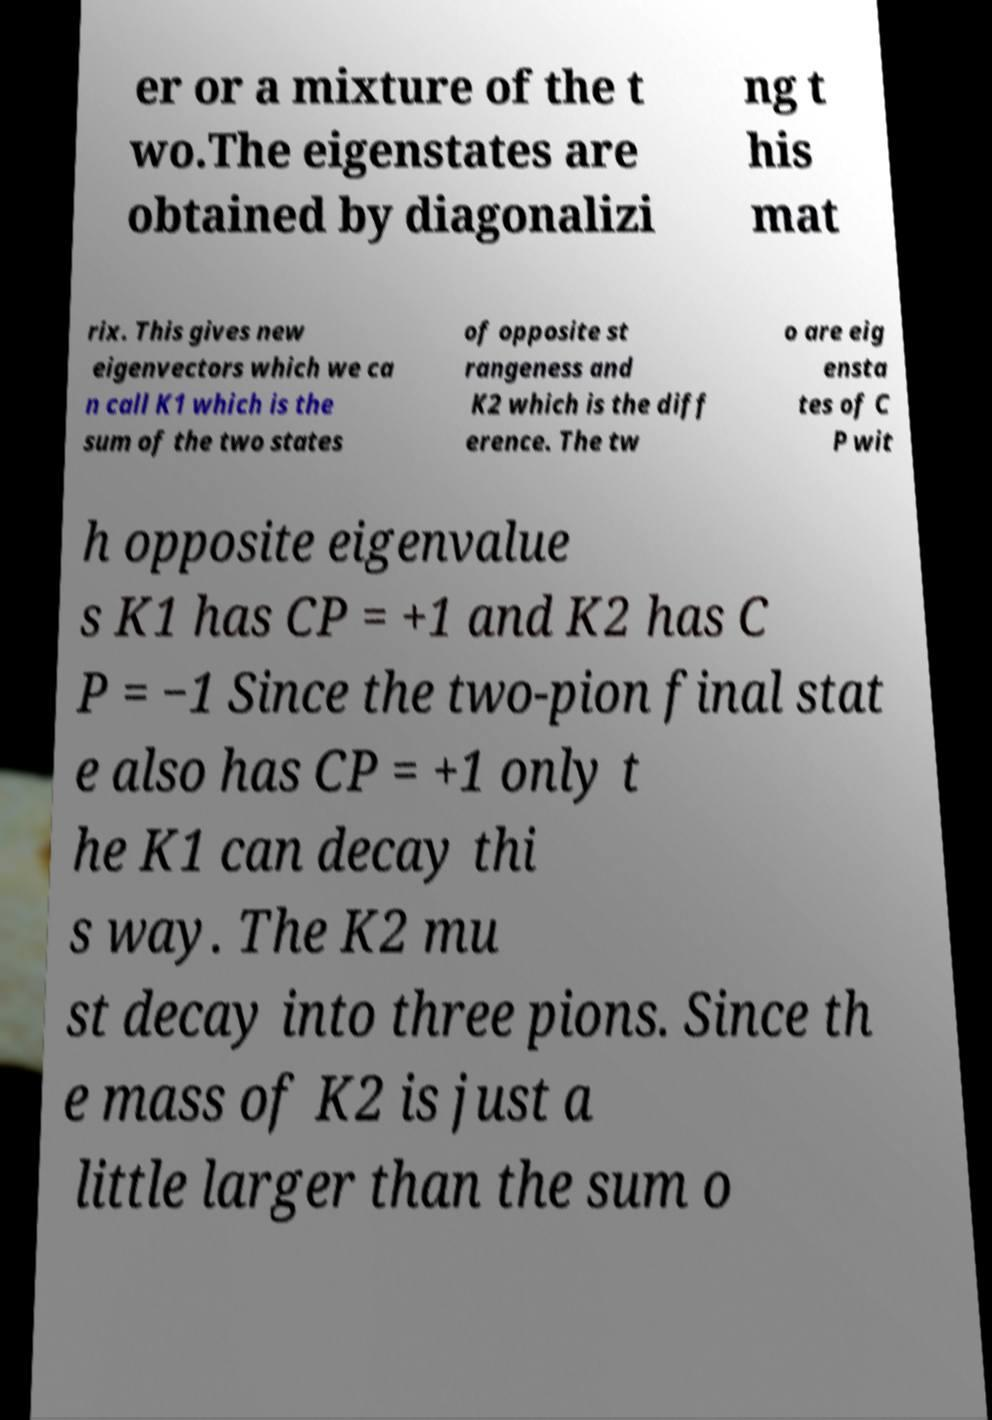There's text embedded in this image that I need extracted. Can you transcribe it verbatim? er or a mixture of the t wo.The eigenstates are obtained by diagonalizi ng t his mat rix. This gives new eigenvectors which we ca n call K1 which is the sum of the two states of opposite st rangeness and K2 which is the diff erence. The tw o are eig ensta tes of C P wit h opposite eigenvalue s K1 has CP = +1 and K2 has C P = −1 Since the two-pion final stat e also has CP = +1 only t he K1 can decay thi s way. The K2 mu st decay into three pions. Since th e mass of K2 is just a little larger than the sum o 